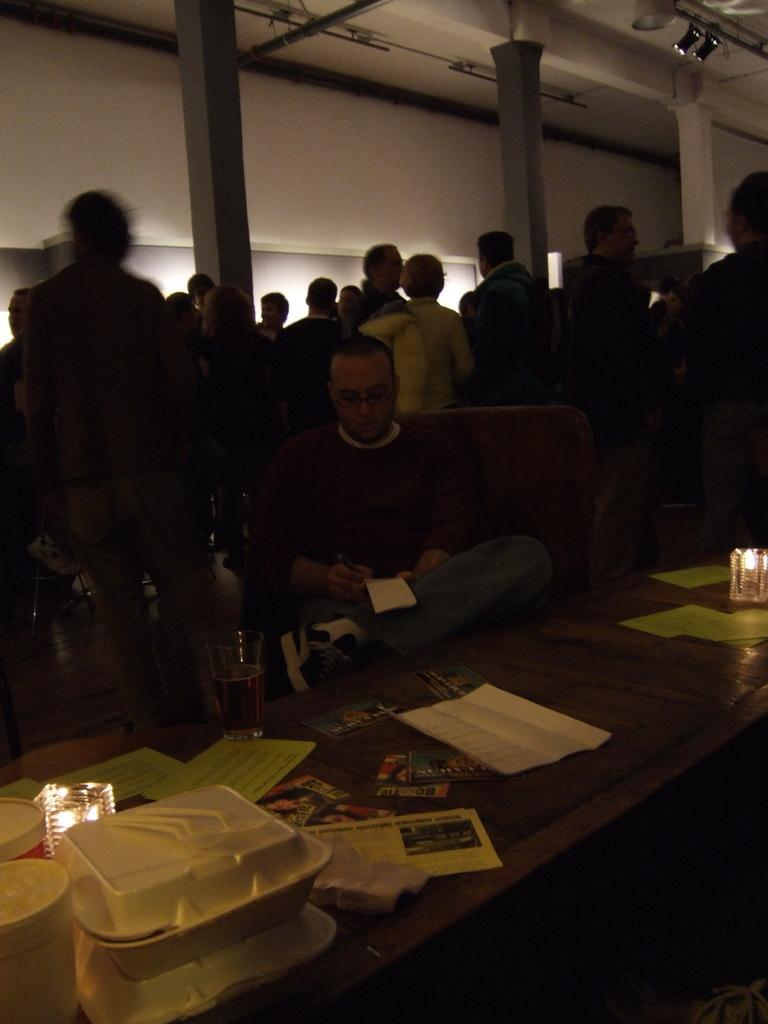What is the man in the image doing? The man is sitting on a chair in the image. What is in front of the man? There is a table in front of the man. What can be seen on the table? There are multiple objects on the table. What can be seen in the background of the image? There are people, pillars, and a wall visible in the background of the image. How much wealth is displayed on the table in the image? There is no indication of wealth in the image; it only shows a man sitting on a chair with a table in front of him and multiple objects on the table. 